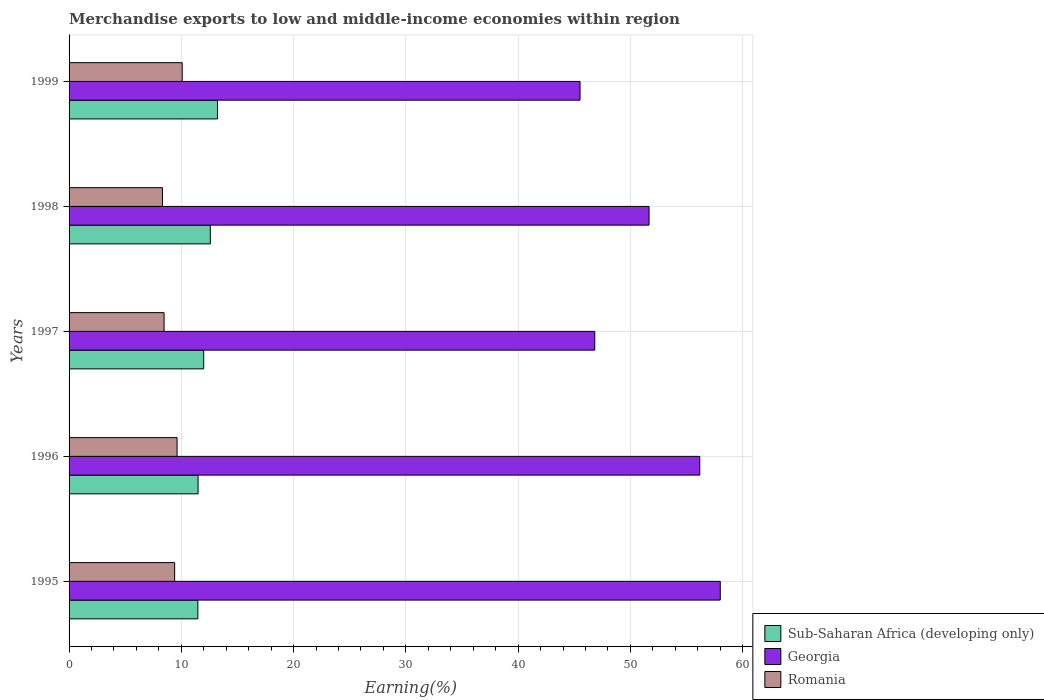How many different coloured bars are there?
Give a very brief answer. 3. Are the number of bars per tick equal to the number of legend labels?
Provide a succinct answer. Yes. Are the number of bars on each tick of the Y-axis equal?
Your response must be concise. Yes. How many bars are there on the 3rd tick from the bottom?
Provide a short and direct response. 3. What is the percentage of amount earned from merchandise exports in Georgia in 1996?
Offer a very short reply. 56.18. Across all years, what is the maximum percentage of amount earned from merchandise exports in Sub-Saharan Africa (developing only)?
Make the answer very short. 13.22. Across all years, what is the minimum percentage of amount earned from merchandise exports in Romania?
Provide a short and direct response. 8.32. In which year was the percentage of amount earned from merchandise exports in Sub-Saharan Africa (developing only) maximum?
Your answer should be compact. 1999. In which year was the percentage of amount earned from merchandise exports in Sub-Saharan Africa (developing only) minimum?
Provide a short and direct response. 1995. What is the total percentage of amount earned from merchandise exports in Sub-Saharan Africa (developing only) in the graph?
Provide a succinct answer. 60.75. What is the difference between the percentage of amount earned from merchandise exports in Romania in 1995 and that in 1997?
Your answer should be very brief. 0.94. What is the difference between the percentage of amount earned from merchandise exports in Georgia in 1996 and the percentage of amount earned from merchandise exports in Sub-Saharan Africa (developing only) in 1998?
Keep it short and to the point. 43.6. What is the average percentage of amount earned from merchandise exports in Romania per year?
Provide a short and direct response. 9.18. In the year 1997, what is the difference between the percentage of amount earned from merchandise exports in Georgia and percentage of amount earned from merchandise exports in Romania?
Your answer should be compact. 38.36. In how many years, is the percentage of amount earned from merchandise exports in Romania greater than 54 %?
Give a very brief answer. 0. What is the ratio of the percentage of amount earned from merchandise exports in Georgia in 1996 to that in 1998?
Provide a succinct answer. 1.09. Is the percentage of amount earned from merchandise exports in Georgia in 1996 less than that in 1998?
Provide a short and direct response. No. Is the difference between the percentage of amount earned from merchandise exports in Georgia in 1997 and 1999 greater than the difference between the percentage of amount earned from merchandise exports in Romania in 1997 and 1999?
Keep it short and to the point. Yes. What is the difference between the highest and the second highest percentage of amount earned from merchandise exports in Sub-Saharan Africa (developing only)?
Provide a succinct answer. 0.64. What is the difference between the highest and the lowest percentage of amount earned from merchandise exports in Romania?
Your answer should be very brief. 1.76. Is the sum of the percentage of amount earned from merchandise exports in Sub-Saharan Africa (developing only) in 1995 and 1998 greater than the maximum percentage of amount earned from merchandise exports in Georgia across all years?
Offer a terse response. No. What does the 2nd bar from the top in 1996 represents?
Your answer should be very brief. Georgia. What does the 3rd bar from the bottom in 1996 represents?
Keep it short and to the point. Romania. Is it the case that in every year, the sum of the percentage of amount earned from merchandise exports in Romania and percentage of amount earned from merchandise exports in Georgia is greater than the percentage of amount earned from merchandise exports in Sub-Saharan Africa (developing only)?
Ensure brevity in your answer.  Yes. How many years are there in the graph?
Make the answer very short. 5. Does the graph contain any zero values?
Provide a short and direct response. No. Does the graph contain grids?
Offer a terse response. Yes. How are the legend labels stacked?
Provide a succinct answer. Vertical. What is the title of the graph?
Ensure brevity in your answer.  Merchandise exports to low and middle-income economies within region. What is the label or title of the X-axis?
Keep it short and to the point. Earning(%). What is the Earning(%) in Sub-Saharan Africa (developing only) in 1995?
Give a very brief answer. 11.47. What is the Earning(%) of Georgia in 1995?
Ensure brevity in your answer.  58. What is the Earning(%) in Romania in 1995?
Provide a succinct answer. 9.4. What is the Earning(%) of Sub-Saharan Africa (developing only) in 1996?
Keep it short and to the point. 11.49. What is the Earning(%) in Georgia in 1996?
Offer a terse response. 56.18. What is the Earning(%) of Romania in 1996?
Offer a terse response. 9.62. What is the Earning(%) of Sub-Saharan Africa (developing only) in 1997?
Make the answer very short. 11.99. What is the Earning(%) in Georgia in 1997?
Give a very brief answer. 46.83. What is the Earning(%) of Romania in 1997?
Your answer should be very brief. 8.46. What is the Earning(%) in Sub-Saharan Africa (developing only) in 1998?
Keep it short and to the point. 12.58. What is the Earning(%) in Georgia in 1998?
Your answer should be compact. 51.66. What is the Earning(%) in Romania in 1998?
Make the answer very short. 8.32. What is the Earning(%) of Sub-Saharan Africa (developing only) in 1999?
Provide a short and direct response. 13.22. What is the Earning(%) of Georgia in 1999?
Keep it short and to the point. 45.51. What is the Earning(%) in Romania in 1999?
Offer a terse response. 10.08. Across all years, what is the maximum Earning(%) in Sub-Saharan Africa (developing only)?
Your answer should be compact. 13.22. Across all years, what is the maximum Earning(%) of Georgia?
Your response must be concise. 58. Across all years, what is the maximum Earning(%) of Romania?
Your answer should be very brief. 10.08. Across all years, what is the minimum Earning(%) of Sub-Saharan Africa (developing only)?
Your answer should be very brief. 11.47. Across all years, what is the minimum Earning(%) of Georgia?
Offer a very short reply. 45.51. Across all years, what is the minimum Earning(%) in Romania?
Offer a terse response. 8.32. What is the total Earning(%) of Sub-Saharan Africa (developing only) in the graph?
Your answer should be very brief. 60.75. What is the total Earning(%) of Georgia in the graph?
Give a very brief answer. 258.18. What is the total Earning(%) of Romania in the graph?
Offer a terse response. 45.88. What is the difference between the Earning(%) of Sub-Saharan Africa (developing only) in 1995 and that in 1996?
Provide a short and direct response. -0.02. What is the difference between the Earning(%) in Georgia in 1995 and that in 1996?
Ensure brevity in your answer.  1.83. What is the difference between the Earning(%) in Romania in 1995 and that in 1996?
Give a very brief answer. -0.21. What is the difference between the Earning(%) in Sub-Saharan Africa (developing only) in 1995 and that in 1997?
Provide a short and direct response. -0.52. What is the difference between the Earning(%) in Georgia in 1995 and that in 1997?
Your answer should be compact. 11.18. What is the difference between the Earning(%) in Romania in 1995 and that in 1997?
Offer a terse response. 0.94. What is the difference between the Earning(%) in Sub-Saharan Africa (developing only) in 1995 and that in 1998?
Provide a succinct answer. -1.11. What is the difference between the Earning(%) of Georgia in 1995 and that in 1998?
Your response must be concise. 6.34. What is the difference between the Earning(%) in Romania in 1995 and that in 1998?
Provide a short and direct response. 1.09. What is the difference between the Earning(%) in Sub-Saharan Africa (developing only) in 1995 and that in 1999?
Provide a short and direct response. -1.74. What is the difference between the Earning(%) in Georgia in 1995 and that in 1999?
Give a very brief answer. 12.49. What is the difference between the Earning(%) in Romania in 1995 and that in 1999?
Your answer should be very brief. -0.67. What is the difference between the Earning(%) in Sub-Saharan Africa (developing only) in 1996 and that in 1997?
Your answer should be compact. -0.5. What is the difference between the Earning(%) in Georgia in 1996 and that in 1997?
Your answer should be compact. 9.35. What is the difference between the Earning(%) in Romania in 1996 and that in 1997?
Make the answer very short. 1.16. What is the difference between the Earning(%) of Sub-Saharan Africa (developing only) in 1996 and that in 1998?
Your response must be concise. -1.09. What is the difference between the Earning(%) of Georgia in 1996 and that in 1998?
Make the answer very short. 4.52. What is the difference between the Earning(%) of Romania in 1996 and that in 1998?
Keep it short and to the point. 1.3. What is the difference between the Earning(%) in Sub-Saharan Africa (developing only) in 1996 and that in 1999?
Offer a very short reply. -1.73. What is the difference between the Earning(%) in Georgia in 1996 and that in 1999?
Provide a succinct answer. 10.66. What is the difference between the Earning(%) of Romania in 1996 and that in 1999?
Your answer should be very brief. -0.46. What is the difference between the Earning(%) in Sub-Saharan Africa (developing only) in 1997 and that in 1998?
Offer a terse response. -0.59. What is the difference between the Earning(%) of Georgia in 1997 and that in 1998?
Provide a succinct answer. -4.83. What is the difference between the Earning(%) of Romania in 1997 and that in 1998?
Provide a short and direct response. 0.15. What is the difference between the Earning(%) in Sub-Saharan Africa (developing only) in 1997 and that in 1999?
Provide a succinct answer. -1.23. What is the difference between the Earning(%) in Georgia in 1997 and that in 1999?
Provide a succinct answer. 1.31. What is the difference between the Earning(%) of Romania in 1997 and that in 1999?
Give a very brief answer. -1.61. What is the difference between the Earning(%) in Sub-Saharan Africa (developing only) in 1998 and that in 1999?
Provide a short and direct response. -0.64. What is the difference between the Earning(%) in Georgia in 1998 and that in 1999?
Provide a short and direct response. 6.15. What is the difference between the Earning(%) of Romania in 1998 and that in 1999?
Your response must be concise. -1.76. What is the difference between the Earning(%) in Sub-Saharan Africa (developing only) in 1995 and the Earning(%) in Georgia in 1996?
Give a very brief answer. -44.7. What is the difference between the Earning(%) of Sub-Saharan Africa (developing only) in 1995 and the Earning(%) of Romania in 1996?
Offer a terse response. 1.85. What is the difference between the Earning(%) in Georgia in 1995 and the Earning(%) in Romania in 1996?
Your answer should be very brief. 48.38. What is the difference between the Earning(%) of Sub-Saharan Africa (developing only) in 1995 and the Earning(%) of Georgia in 1997?
Provide a succinct answer. -35.35. What is the difference between the Earning(%) of Sub-Saharan Africa (developing only) in 1995 and the Earning(%) of Romania in 1997?
Offer a very short reply. 3.01. What is the difference between the Earning(%) in Georgia in 1995 and the Earning(%) in Romania in 1997?
Provide a short and direct response. 49.54. What is the difference between the Earning(%) in Sub-Saharan Africa (developing only) in 1995 and the Earning(%) in Georgia in 1998?
Your response must be concise. -40.19. What is the difference between the Earning(%) of Sub-Saharan Africa (developing only) in 1995 and the Earning(%) of Romania in 1998?
Your answer should be compact. 3.15. What is the difference between the Earning(%) of Georgia in 1995 and the Earning(%) of Romania in 1998?
Give a very brief answer. 49.68. What is the difference between the Earning(%) of Sub-Saharan Africa (developing only) in 1995 and the Earning(%) of Georgia in 1999?
Your answer should be compact. -34.04. What is the difference between the Earning(%) in Sub-Saharan Africa (developing only) in 1995 and the Earning(%) in Romania in 1999?
Your answer should be very brief. 1.4. What is the difference between the Earning(%) in Georgia in 1995 and the Earning(%) in Romania in 1999?
Your answer should be very brief. 47.93. What is the difference between the Earning(%) in Sub-Saharan Africa (developing only) in 1996 and the Earning(%) in Georgia in 1997?
Provide a succinct answer. -35.34. What is the difference between the Earning(%) of Sub-Saharan Africa (developing only) in 1996 and the Earning(%) of Romania in 1997?
Your response must be concise. 3.03. What is the difference between the Earning(%) in Georgia in 1996 and the Earning(%) in Romania in 1997?
Ensure brevity in your answer.  47.71. What is the difference between the Earning(%) in Sub-Saharan Africa (developing only) in 1996 and the Earning(%) in Georgia in 1998?
Your answer should be compact. -40.17. What is the difference between the Earning(%) of Sub-Saharan Africa (developing only) in 1996 and the Earning(%) of Romania in 1998?
Your answer should be compact. 3.17. What is the difference between the Earning(%) in Georgia in 1996 and the Earning(%) in Romania in 1998?
Provide a short and direct response. 47.86. What is the difference between the Earning(%) of Sub-Saharan Africa (developing only) in 1996 and the Earning(%) of Georgia in 1999?
Offer a very short reply. -34.02. What is the difference between the Earning(%) of Sub-Saharan Africa (developing only) in 1996 and the Earning(%) of Romania in 1999?
Your answer should be compact. 1.41. What is the difference between the Earning(%) of Georgia in 1996 and the Earning(%) of Romania in 1999?
Your response must be concise. 46.1. What is the difference between the Earning(%) of Sub-Saharan Africa (developing only) in 1997 and the Earning(%) of Georgia in 1998?
Your response must be concise. -39.67. What is the difference between the Earning(%) in Sub-Saharan Africa (developing only) in 1997 and the Earning(%) in Romania in 1998?
Offer a very short reply. 3.67. What is the difference between the Earning(%) in Georgia in 1997 and the Earning(%) in Romania in 1998?
Keep it short and to the point. 38.51. What is the difference between the Earning(%) of Sub-Saharan Africa (developing only) in 1997 and the Earning(%) of Georgia in 1999?
Provide a succinct answer. -33.52. What is the difference between the Earning(%) of Sub-Saharan Africa (developing only) in 1997 and the Earning(%) of Romania in 1999?
Provide a succinct answer. 1.91. What is the difference between the Earning(%) in Georgia in 1997 and the Earning(%) in Romania in 1999?
Offer a very short reply. 36.75. What is the difference between the Earning(%) in Sub-Saharan Africa (developing only) in 1998 and the Earning(%) in Georgia in 1999?
Provide a short and direct response. -32.93. What is the difference between the Earning(%) of Sub-Saharan Africa (developing only) in 1998 and the Earning(%) of Romania in 1999?
Provide a short and direct response. 2.5. What is the difference between the Earning(%) of Georgia in 1998 and the Earning(%) of Romania in 1999?
Keep it short and to the point. 41.58. What is the average Earning(%) of Sub-Saharan Africa (developing only) per year?
Make the answer very short. 12.15. What is the average Earning(%) in Georgia per year?
Your response must be concise. 51.64. What is the average Earning(%) in Romania per year?
Keep it short and to the point. 9.18. In the year 1995, what is the difference between the Earning(%) in Sub-Saharan Africa (developing only) and Earning(%) in Georgia?
Provide a succinct answer. -46.53. In the year 1995, what is the difference between the Earning(%) in Sub-Saharan Africa (developing only) and Earning(%) in Romania?
Make the answer very short. 2.07. In the year 1995, what is the difference between the Earning(%) in Georgia and Earning(%) in Romania?
Offer a very short reply. 48.6. In the year 1996, what is the difference between the Earning(%) of Sub-Saharan Africa (developing only) and Earning(%) of Georgia?
Give a very brief answer. -44.69. In the year 1996, what is the difference between the Earning(%) in Sub-Saharan Africa (developing only) and Earning(%) in Romania?
Offer a terse response. 1.87. In the year 1996, what is the difference between the Earning(%) of Georgia and Earning(%) of Romania?
Make the answer very short. 46.56. In the year 1997, what is the difference between the Earning(%) of Sub-Saharan Africa (developing only) and Earning(%) of Georgia?
Keep it short and to the point. -34.84. In the year 1997, what is the difference between the Earning(%) of Sub-Saharan Africa (developing only) and Earning(%) of Romania?
Make the answer very short. 3.53. In the year 1997, what is the difference between the Earning(%) of Georgia and Earning(%) of Romania?
Your response must be concise. 38.36. In the year 1998, what is the difference between the Earning(%) of Sub-Saharan Africa (developing only) and Earning(%) of Georgia?
Provide a succinct answer. -39.08. In the year 1998, what is the difference between the Earning(%) of Sub-Saharan Africa (developing only) and Earning(%) of Romania?
Provide a short and direct response. 4.26. In the year 1998, what is the difference between the Earning(%) of Georgia and Earning(%) of Romania?
Make the answer very short. 43.34. In the year 1999, what is the difference between the Earning(%) of Sub-Saharan Africa (developing only) and Earning(%) of Georgia?
Make the answer very short. -32.3. In the year 1999, what is the difference between the Earning(%) of Sub-Saharan Africa (developing only) and Earning(%) of Romania?
Provide a succinct answer. 3.14. In the year 1999, what is the difference between the Earning(%) in Georgia and Earning(%) in Romania?
Your response must be concise. 35.44. What is the ratio of the Earning(%) in Sub-Saharan Africa (developing only) in 1995 to that in 1996?
Offer a terse response. 1. What is the ratio of the Earning(%) in Georgia in 1995 to that in 1996?
Ensure brevity in your answer.  1.03. What is the ratio of the Earning(%) in Romania in 1995 to that in 1996?
Your answer should be compact. 0.98. What is the ratio of the Earning(%) of Sub-Saharan Africa (developing only) in 1995 to that in 1997?
Provide a succinct answer. 0.96. What is the ratio of the Earning(%) in Georgia in 1995 to that in 1997?
Your answer should be very brief. 1.24. What is the ratio of the Earning(%) in Romania in 1995 to that in 1997?
Keep it short and to the point. 1.11. What is the ratio of the Earning(%) in Sub-Saharan Africa (developing only) in 1995 to that in 1998?
Give a very brief answer. 0.91. What is the ratio of the Earning(%) in Georgia in 1995 to that in 1998?
Provide a short and direct response. 1.12. What is the ratio of the Earning(%) of Romania in 1995 to that in 1998?
Give a very brief answer. 1.13. What is the ratio of the Earning(%) in Sub-Saharan Africa (developing only) in 1995 to that in 1999?
Provide a succinct answer. 0.87. What is the ratio of the Earning(%) in Georgia in 1995 to that in 1999?
Provide a short and direct response. 1.27. What is the ratio of the Earning(%) in Romania in 1995 to that in 1999?
Your answer should be compact. 0.93. What is the ratio of the Earning(%) of Sub-Saharan Africa (developing only) in 1996 to that in 1997?
Keep it short and to the point. 0.96. What is the ratio of the Earning(%) in Georgia in 1996 to that in 1997?
Provide a short and direct response. 1.2. What is the ratio of the Earning(%) in Romania in 1996 to that in 1997?
Ensure brevity in your answer.  1.14. What is the ratio of the Earning(%) of Sub-Saharan Africa (developing only) in 1996 to that in 1998?
Provide a short and direct response. 0.91. What is the ratio of the Earning(%) of Georgia in 1996 to that in 1998?
Your response must be concise. 1.09. What is the ratio of the Earning(%) in Romania in 1996 to that in 1998?
Offer a terse response. 1.16. What is the ratio of the Earning(%) in Sub-Saharan Africa (developing only) in 1996 to that in 1999?
Offer a terse response. 0.87. What is the ratio of the Earning(%) in Georgia in 1996 to that in 1999?
Offer a very short reply. 1.23. What is the ratio of the Earning(%) of Romania in 1996 to that in 1999?
Your response must be concise. 0.95. What is the ratio of the Earning(%) of Sub-Saharan Africa (developing only) in 1997 to that in 1998?
Ensure brevity in your answer.  0.95. What is the ratio of the Earning(%) of Georgia in 1997 to that in 1998?
Offer a very short reply. 0.91. What is the ratio of the Earning(%) of Romania in 1997 to that in 1998?
Keep it short and to the point. 1.02. What is the ratio of the Earning(%) in Sub-Saharan Africa (developing only) in 1997 to that in 1999?
Give a very brief answer. 0.91. What is the ratio of the Earning(%) of Georgia in 1997 to that in 1999?
Make the answer very short. 1.03. What is the ratio of the Earning(%) in Romania in 1997 to that in 1999?
Make the answer very short. 0.84. What is the ratio of the Earning(%) in Sub-Saharan Africa (developing only) in 1998 to that in 1999?
Make the answer very short. 0.95. What is the ratio of the Earning(%) of Georgia in 1998 to that in 1999?
Give a very brief answer. 1.14. What is the ratio of the Earning(%) in Romania in 1998 to that in 1999?
Your answer should be very brief. 0.83. What is the difference between the highest and the second highest Earning(%) in Sub-Saharan Africa (developing only)?
Keep it short and to the point. 0.64. What is the difference between the highest and the second highest Earning(%) of Georgia?
Offer a terse response. 1.83. What is the difference between the highest and the second highest Earning(%) in Romania?
Offer a terse response. 0.46. What is the difference between the highest and the lowest Earning(%) in Sub-Saharan Africa (developing only)?
Make the answer very short. 1.74. What is the difference between the highest and the lowest Earning(%) in Georgia?
Your answer should be compact. 12.49. What is the difference between the highest and the lowest Earning(%) in Romania?
Your answer should be very brief. 1.76. 